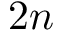<formula> <loc_0><loc_0><loc_500><loc_500>2 n</formula> 